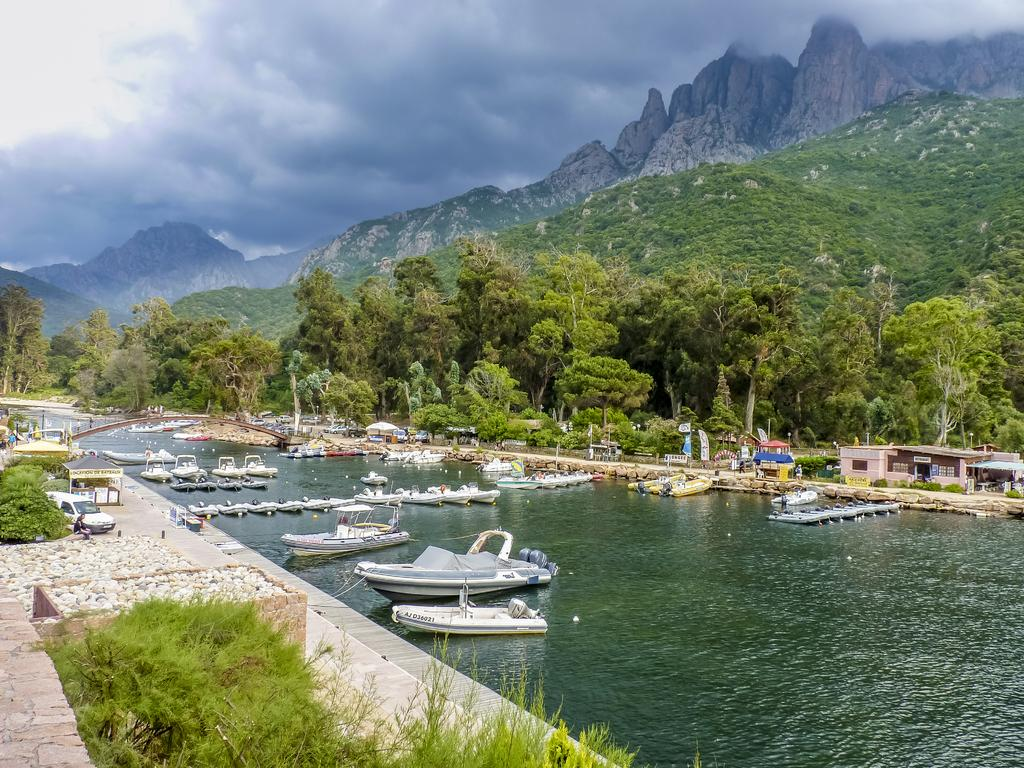What is the main subject in the center of the image? There is water in the center of the image. What else can be seen in the image besides the water? There are ships, trees, and mountains in the image. What is visible in the background of the image? There are mountains in the background of the image. What is visible at the top of the image? There are clouds at the top of the image. What type of suit is the water wearing in the image? The water is not wearing a suit, as it is a natural element and does not have the ability to wear clothing. 